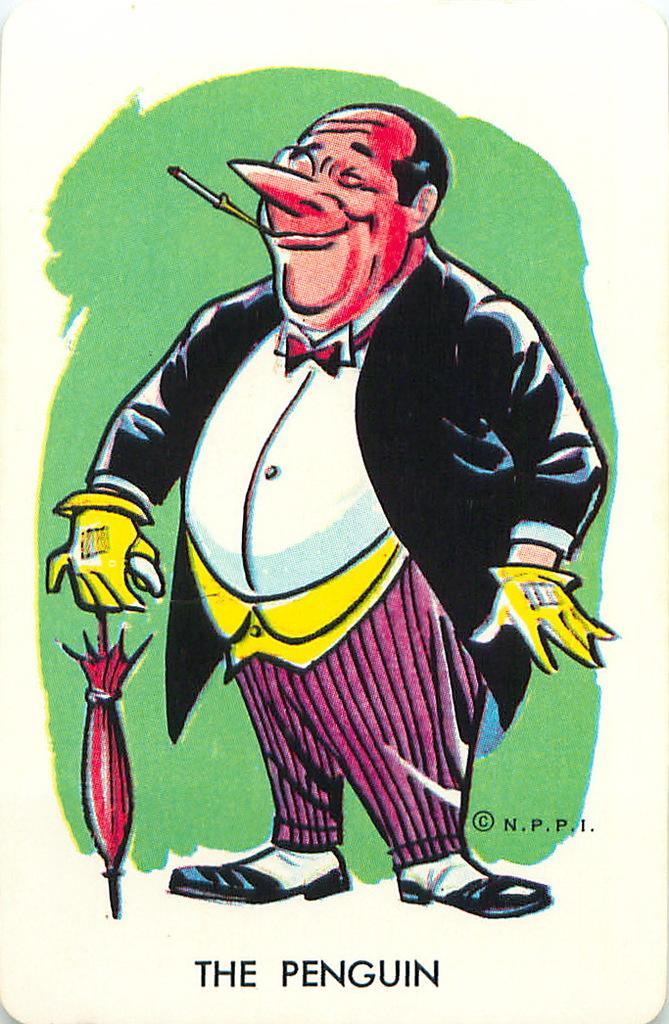How would you summarize this image in a sentence or two? In this picture I can see a cartoon image of a man and I can see text at the bottom of the picture. 